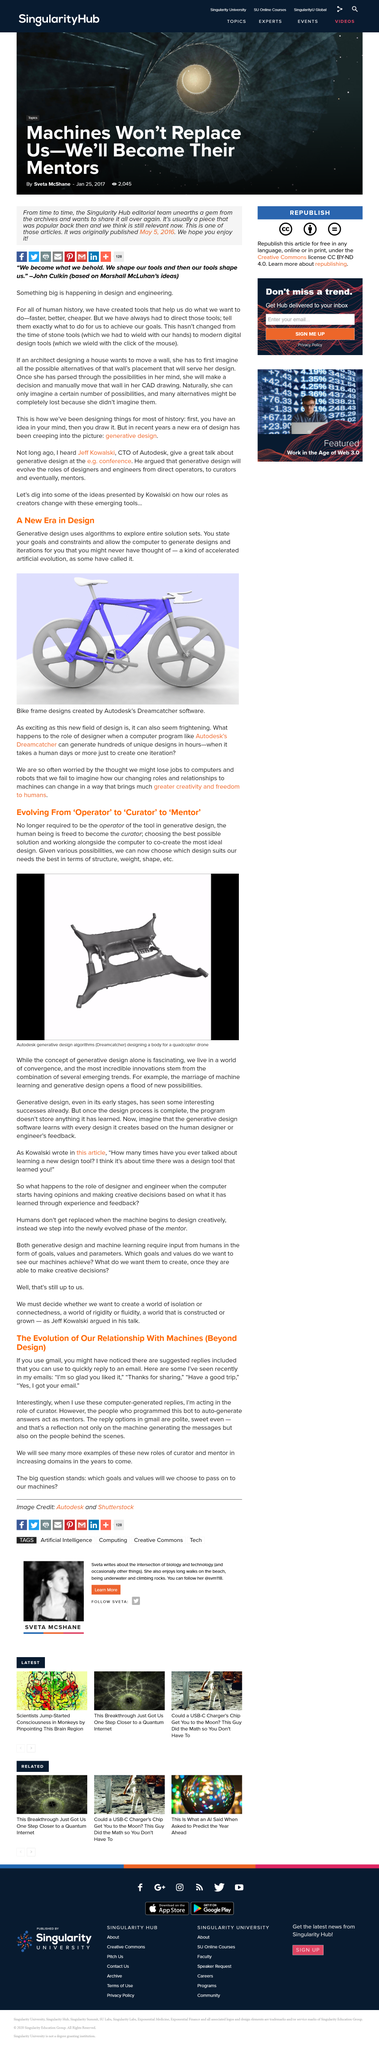Highlight a few significant elements in this photo. Examples of computer-generated replies, such as "I'm so glad you liked it," "Thanks for sharing," "Have a good trip," and "Yes, I got your email," are computer-generated responses that are commonly used in various contexts. Generative design uses algorithms to explore entire solution sets, allowing for the creation of innovative and optimal designs. The individuals who developed the bot to automatically generate responses are the mentors for this platform. Autodesk's Dreamcatcher program has the capability to generate hundreds of architectural designs within just a few hours, making it a powerful tool for architects and designers. The first name of the person to whom the opening quote is attributed is John. 